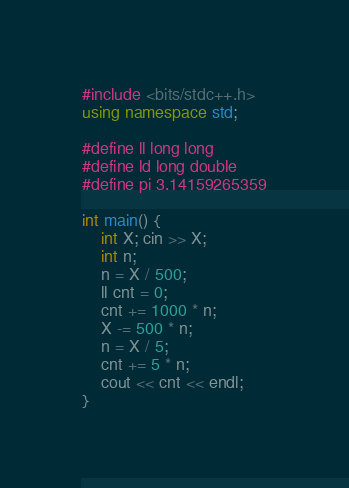Convert code to text. <code><loc_0><loc_0><loc_500><loc_500><_C++_>#include <bits/stdc++.h>
using namespace std;

#define ll long long
#define ld long double
#define pi 3.14159265359

int main() {
    int X; cin >> X;
    int n; 
    n = X / 500;
    ll cnt = 0;
    cnt += 1000 * n;
    X -= 500 * n;
    n = X / 5;
    cnt += 5 * n;
    cout << cnt << endl;
}</code> 